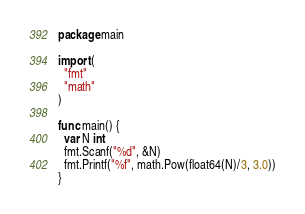Convert code to text. <code><loc_0><loc_0><loc_500><loc_500><_Go_>package main

import (
  "fmt"
  "math"
)

func main() {
  var N int
  fmt.Scanf("%d", &N)
  fmt.Printf("%f", math.Pow(float64(N)/3, 3.0))
}
</code> 